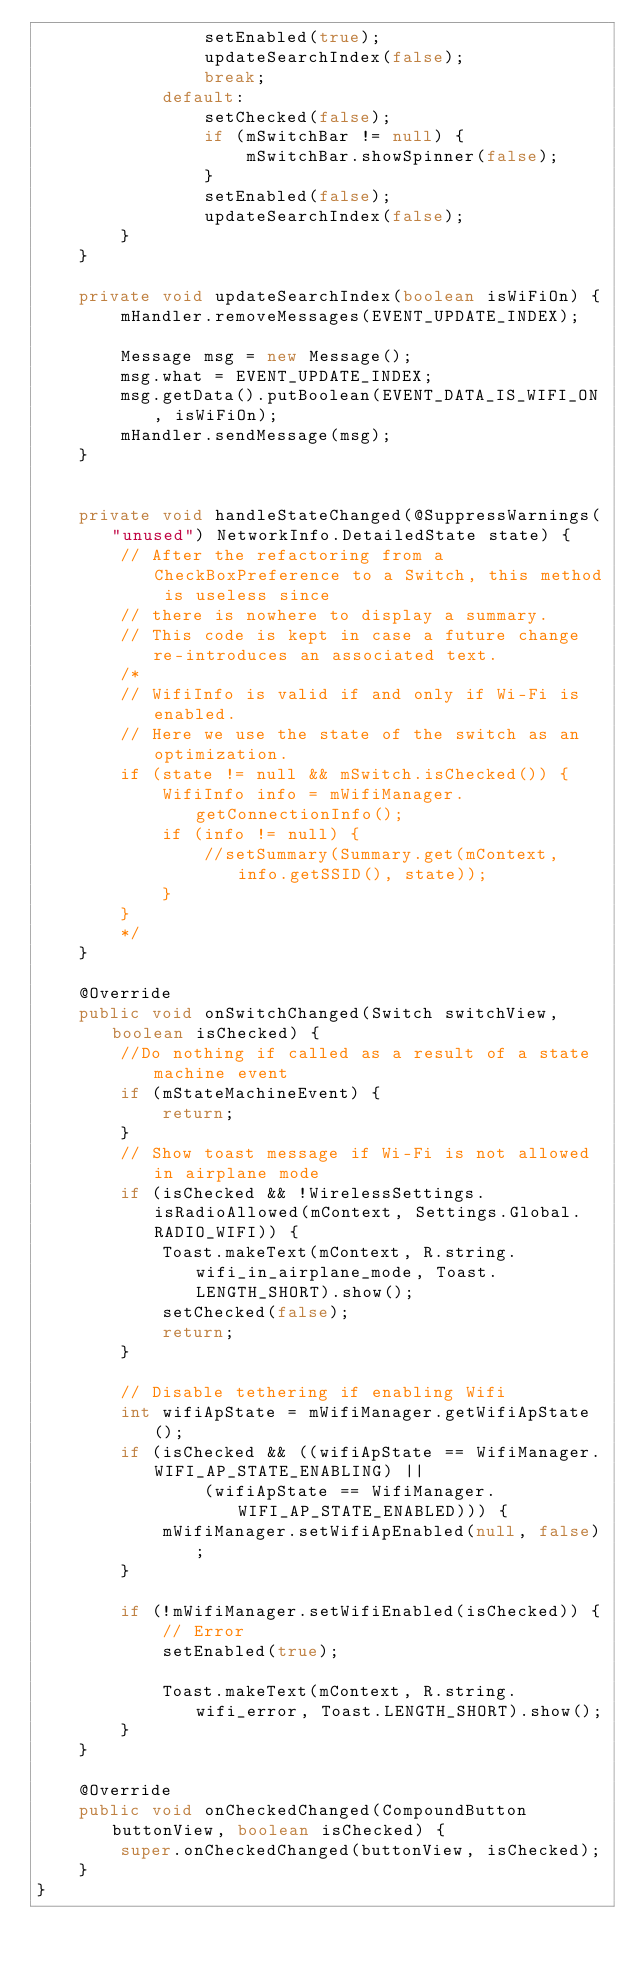Convert code to text. <code><loc_0><loc_0><loc_500><loc_500><_Java_>                setEnabled(true);
                updateSearchIndex(false);
                break;
            default:
                setChecked(false);
                if (mSwitchBar != null) {
                    mSwitchBar.showSpinner(false);
                }
                setEnabled(false);
                updateSearchIndex(false);
        }
    }

    private void updateSearchIndex(boolean isWiFiOn) {
        mHandler.removeMessages(EVENT_UPDATE_INDEX);

        Message msg = new Message();
        msg.what = EVENT_UPDATE_INDEX;
        msg.getData().putBoolean(EVENT_DATA_IS_WIFI_ON, isWiFiOn);
        mHandler.sendMessage(msg);
    }


    private void handleStateChanged(@SuppressWarnings("unused") NetworkInfo.DetailedState state) {
        // After the refactoring from a CheckBoxPreference to a Switch, this method is useless since
        // there is nowhere to display a summary.
        // This code is kept in case a future change re-introduces an associated text.
        /*
        // WifiInfo is valid if and only if Wi-Fi is enabled.
        // Here we use the state of the switch as an optimization.
        if (state != null && mSwitch.isChecked()) {
            WifiInfo info = mWifiManager.getConnectionInfo();
            if (info != null) {
                //setSummary(Summary.get(mContext, info.getSSID(), state));
            }
        }
        */
    }

    @Override
    public void onSwitchChanged(Switch switchView, boolean isChecked) {
        //Do nothing if called as a result of a state machine event
        if (mStateMachineEvent) {
            return;
        }
        // Show toast message if Wi-Fi is not allowed in airplane mode
        if (isChecked && !WirelessSettings.isRadioAllowed(mContext, Settings.Global.RADIO_WIFI)) {
            Toast.makeText(mContext, R.string.wifi_in_airplane_mode, Toast.LENGTH_SHORT).show();
            setChecked(false);
            return;
        }

        // Disable tethering if enabling Wifi
        int wifiApState = mWifiManager.getWifiApState();
        if (isChecked && ((wifiApState == WifiManager.WIFI_AP_STATE_ENABLING) ||
                (wifiApState == WifiManager.WIFI_AP_STATE_ENABLED))) {
            mWifiManager.setWifiApEnabled(null, false);
        }

        if (!mWifiManager.setWifiEnabled(isChecked)) {
            // Error
            setEnabled(true);

            Toast.makeText(mContext, R.string.wifi_error, Toast.LENGTH_SHORT).show();
        }
    }

    @Override
    public void onCheckedChanged(CompoundButton buttonView, boolean isChecked) {
        super.onCheckedChanged(buttonView, isChecked);
    }
}
</code> 